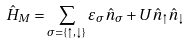<formula> <loc_0><loc_0><loc_500><loc_500>\hat { H } _ { M } = \sum _ { \sigma = \{ \uparrow , \downarrow \} } \varepsilon _ { \sigma } \hat { n } _ { \sigma } + U \hat { n } _ { \uparrow } \hat { n } _ { \downarrow }</formula> 